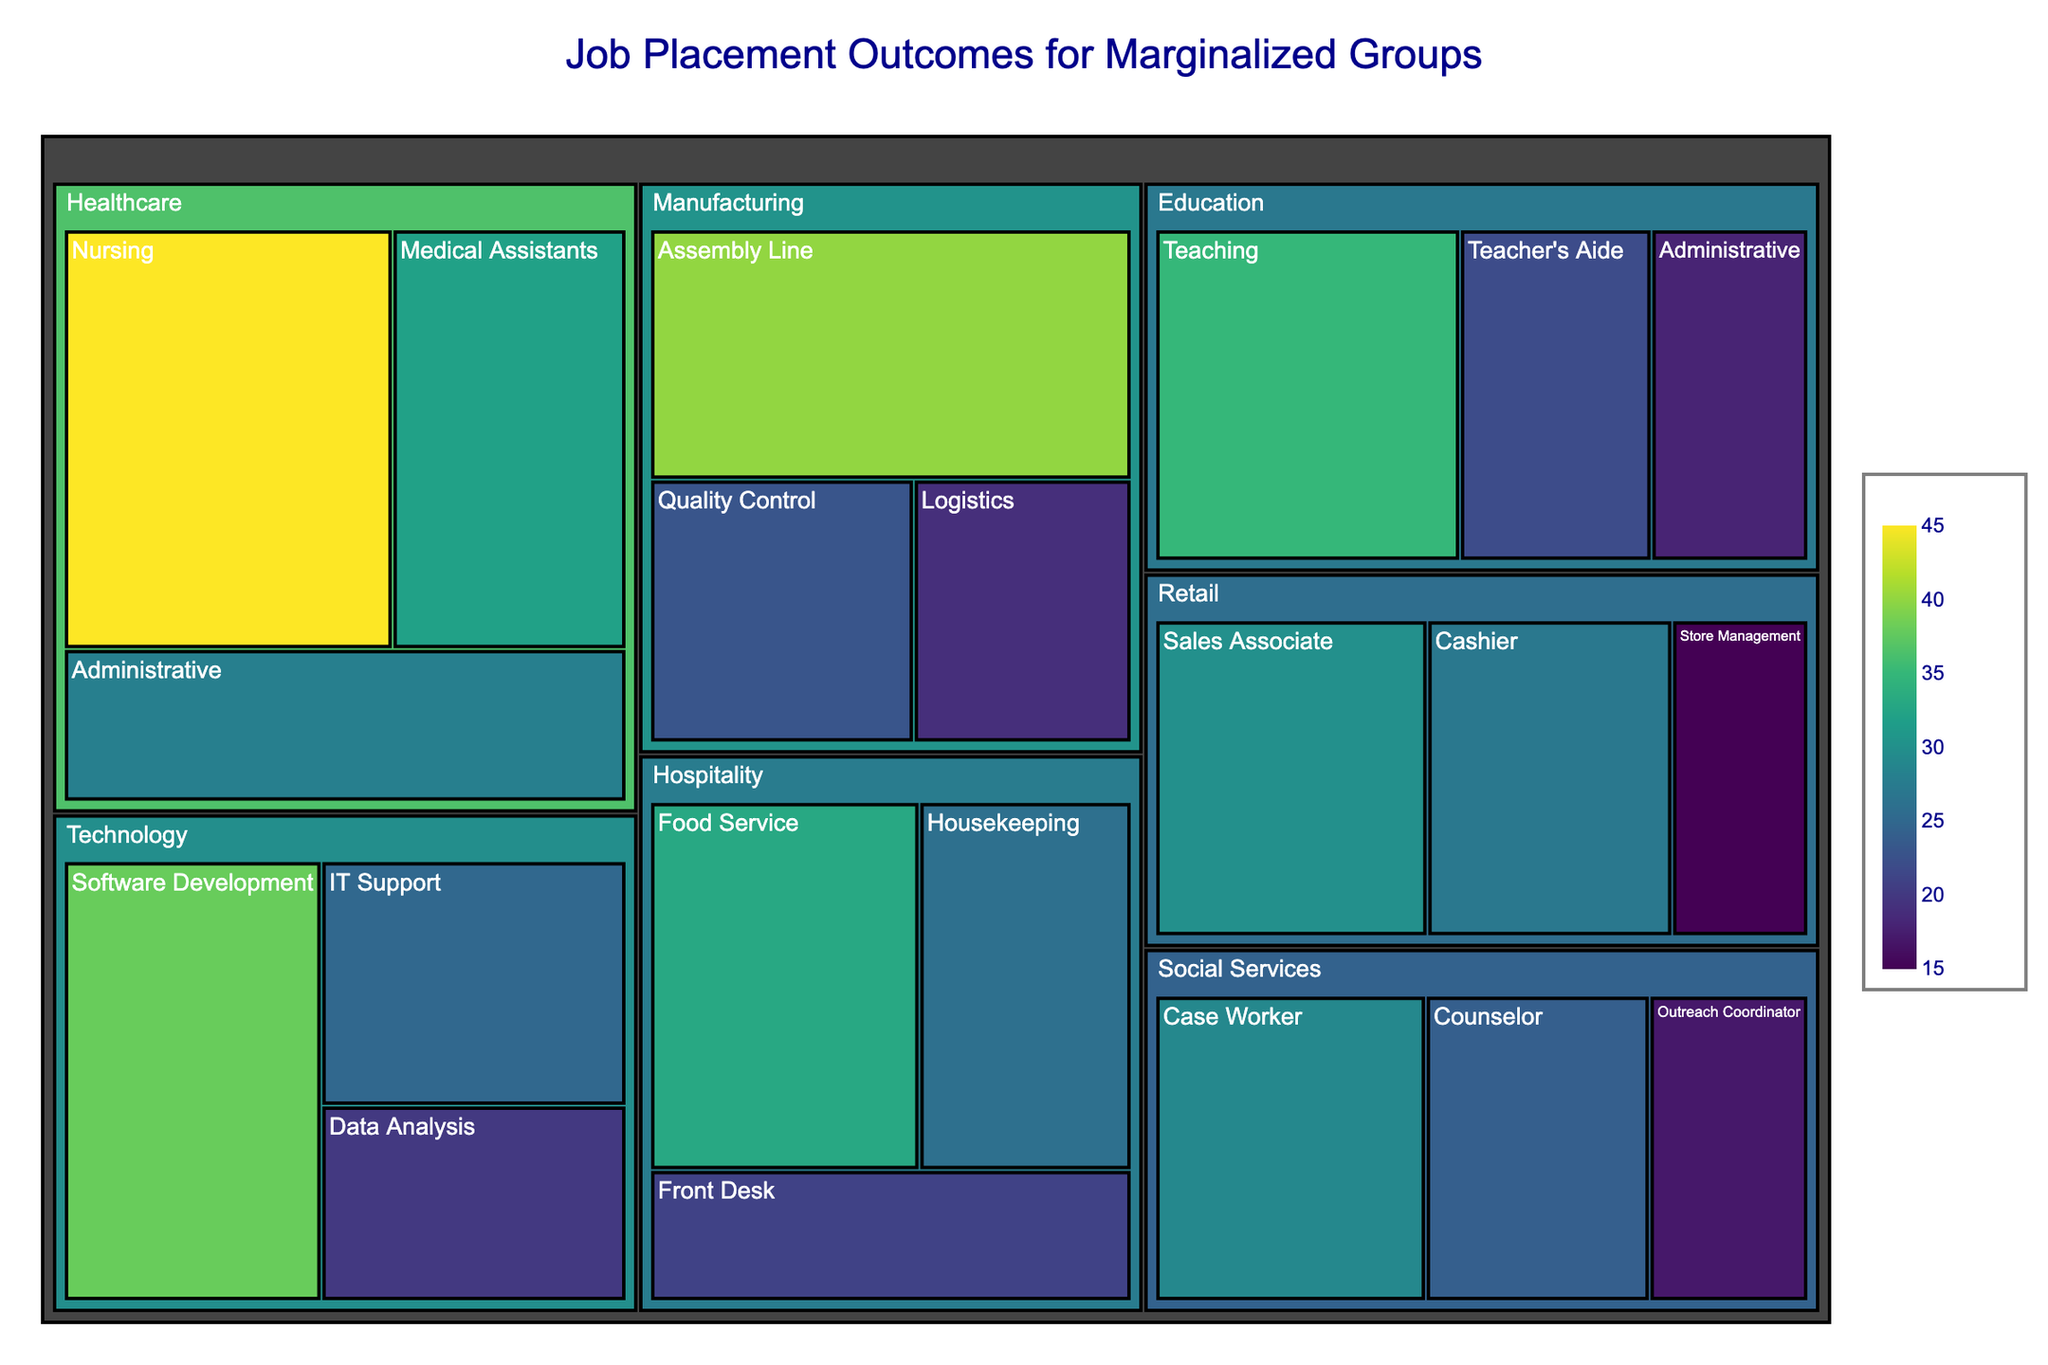what is the total number of job placements in the Healthcare industry? To find the total number of job placements in the Healthcare industry, look at each job type within this industry and sum their placements: Nursing (45) + Medical Assistants (32) + Administrative (28) = 45 + 32 + 28 = 105
Answer: 105 which job type in the Technology industry has the highest number of placements? To determine which job type in the Technology industry has the highest placements, compare the given values: Software Development (38), IT Support (25), Data Analysis (20). Software Development has the highest number (38)
Answer: Software Development How many more placements are there in Healthcare compared to Social Services? First, find the total placements in Healthcare: Nursing (45) + Medical Assistants (32) + Administrative (28) = 105. Then find the total placements in Social Services: Case Worker (29) + Counselor (24) + Outreach Coordinator (17) = 70. Finally, compute the difference: 105 - 70 = 35
Answer: 35 what is the average number of placements across all job types in the Manufacturing industry? To find the average number of placements, sum the placements in Manufacturing (Assembly Line: 40, Quality Control: 23, Logistics: 19) which gives 40 + 23 + 19 = 82, then divide by the number of job types (3): 82 / 3 ≈ 27.33
Answer: 27.33 is the number of placements for Cashier roles in Retail higher or lower than the number of placements for Housekeeping in Hospitality? Cashier roles in Retail have 27 placements, and Housekeeping in Hospitality has 26 placements. Since 27 > 26, Cashier roles have more placements
Answer: Higher which industry has the most diverse range of job types based on the number of different job types listed? Healthcare, Technology, Education, Manufacturing, Retail, Hospitality, and Social Services all have 3 job types each, so they all have an equally diverse range of job types
Answer: All industries have the same diversity what is the highest number of placements for any single job type? To find the highest number of placements for any job type, look at the values across all fields. The highest value is Nursing in Healthcare with 45 placements
Answer: 45 what percentage of Technology job placements does Software Development account for? First, find the total placements in Technology: Software Development (38) + IT Support (25) + Data Analysis (20) = 83. Then, calculate the percentage: (Software Development / Total Technology placements) * 100 = (38 / 83) * 100 ≈ 45.78%
Answer: 45.78% how do the total placements in Education compare to Hospitality? The total placements in Education are: Teaching (35) + Teacher's Aide (22) + Administrative (18) = 75. The total placements in Hospitality are Food Service (33) + Housekeeping (26) + Front Desk (21) = 80. Education has 75 placements which is less than Hospitality's 80
Answer: Hospitality has more which job type in the Social Services industry has the lowest number of placements? To find the job type with the lowest placements in Social Services, compare the values: Case Worker (29), Counselor (24), and Outreach Coordinator (17). Outreach Coordinator has the lowest number of placements
Answer: Outreach Coordinator 